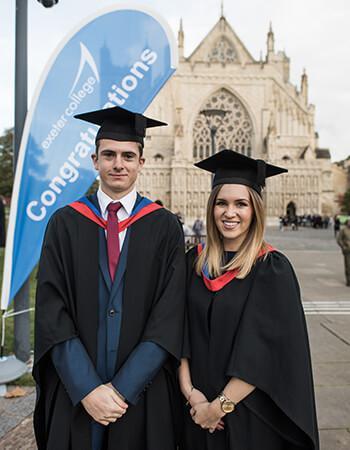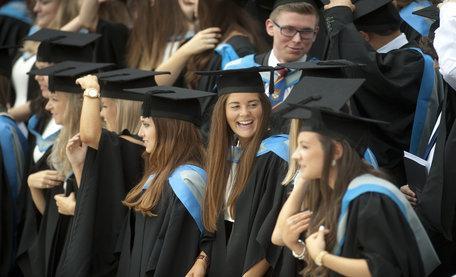The first image is the image on the left, the second image is the image on the right. Evaluate the accuracy of this statement regarding the images: "The right image shows multiple black-robed graduates wearing caps and  bright sky-blue sashes.". Is it true? Answer yes or no. Yes. The first image is the image on the left, the second image is the image on the right. Assess this claim about the two images: "Two graduates stand together outside posing for a picture in the image on the left.". Correct or not? Answer yes or no. Yes. 